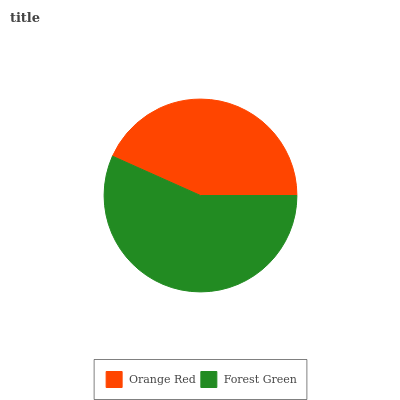Is Orange Red the minimum?
Answer yes or no. Yes. Is Forest Green the maximum?
Answer yes or no. Yes. Is Forest Green the minimum?
Answer yes or no. No. Is Forest Green greater than Orange Red?
Answer yes or no. Yes. Is Orange Red less than Forest Green?
Answer yes or no. Yes. Is Orange Red greater than Forest Green?
Answer yes or no. No. Is Forest Green less than Orange Red?
Answer yes or no. No. Is Forest Green the high median?
Answer yes or no. Yes. Is Orange Red the low median?
Answer yes or no. Yes. Is Orange Red the high median?
Answer yes or no. No. Is Forest Green the low median?
Answer yes or no. No. 